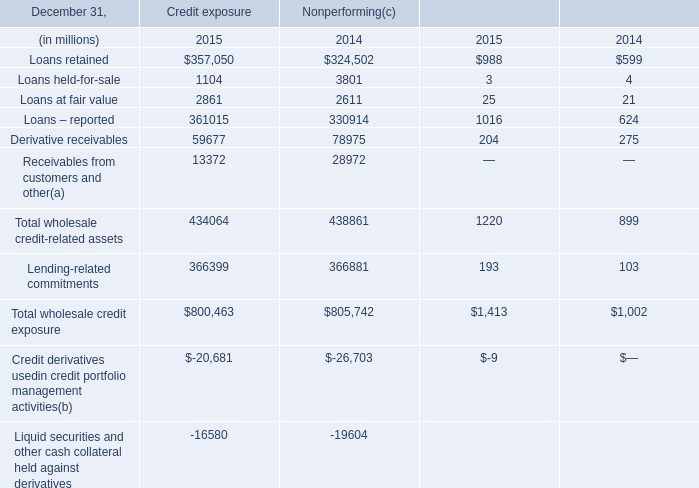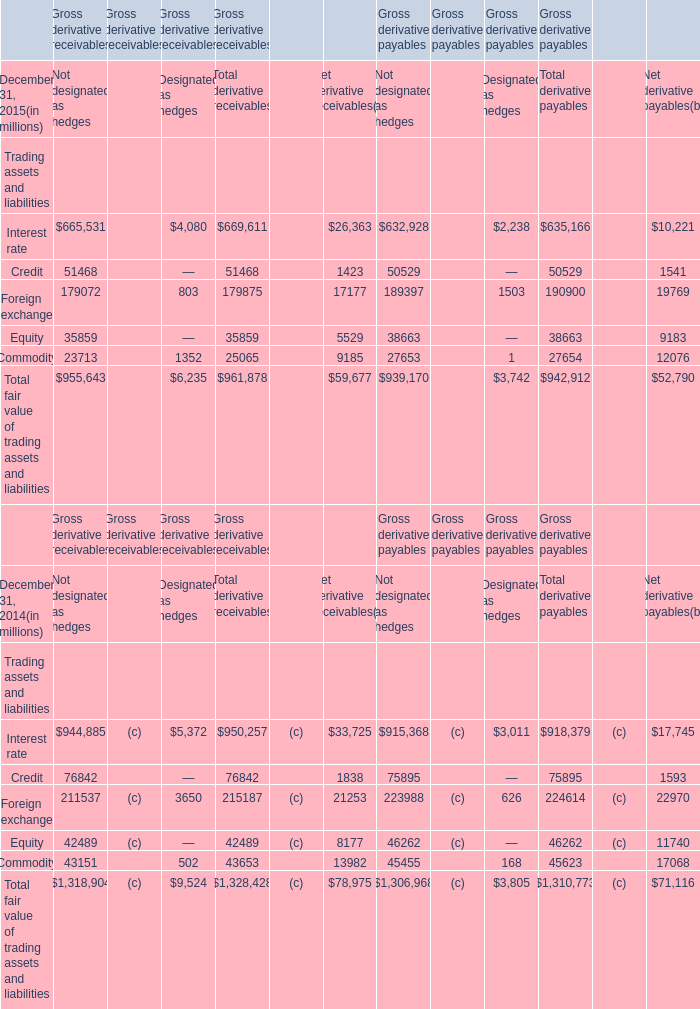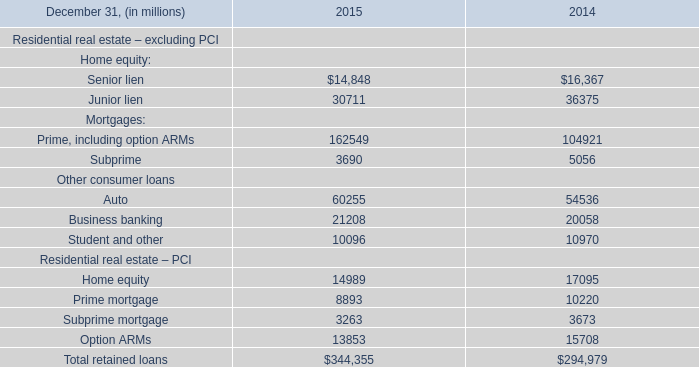What is the percentage of all Trading assets and liabilities that are positive to the total amount, in 2015? 
Computations: ((961878 + 942912) / (961878 + 942912))
Answer: 1.0. 